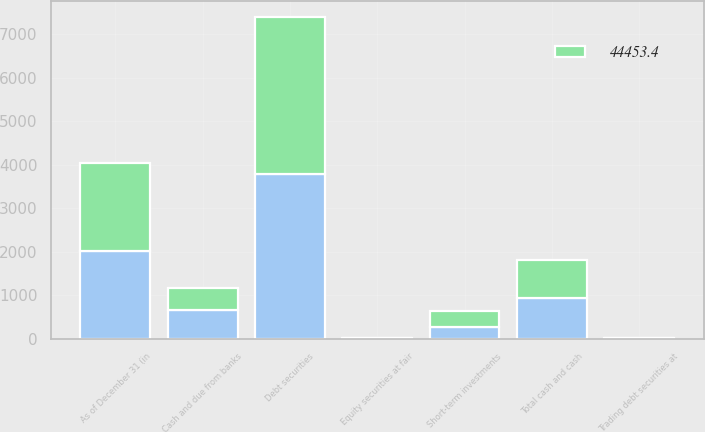<chart> <loc_0><loc_0><loc_500><loc_500><stacked_bar_chart><ecel><fcel>As of December 31 (in<fcel>Cash and due from banks<fcel>Short-term investments<fcel>Total cash and cash<fcel>Trading debt securities at<fcel>Equity securities at fair<fcel>Debt securities<nl><fcel>nan<fcel>2018<fcel>665.7<fcel>266.3<fcel>932<fcel>8.4<fcel>8.1<fcel>3792.3<nl><fcel>44453.4<fcel>2017<fcel>505.1<fcel>377.5<fcel>882.6<fcel>8.2<fcel>8.7<fcel>3588.1<nl></chart> 